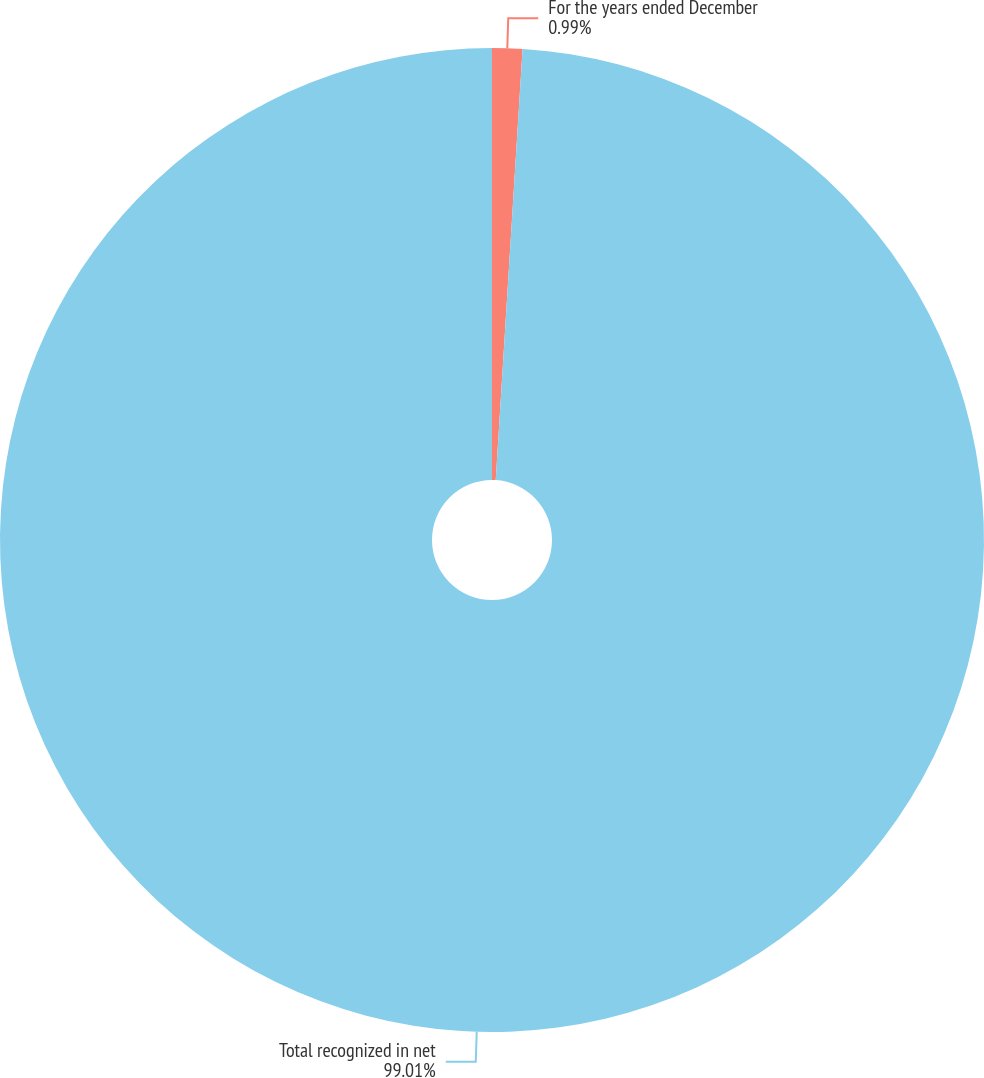Convert chart. <chart><loc_0><loc_0><loc_500><loc_500><pie_chart><fcel>For the years ended December<fcel>Total recognized in net<nl><fcel>0.99%<fcel>99.01%<nl></chart> 